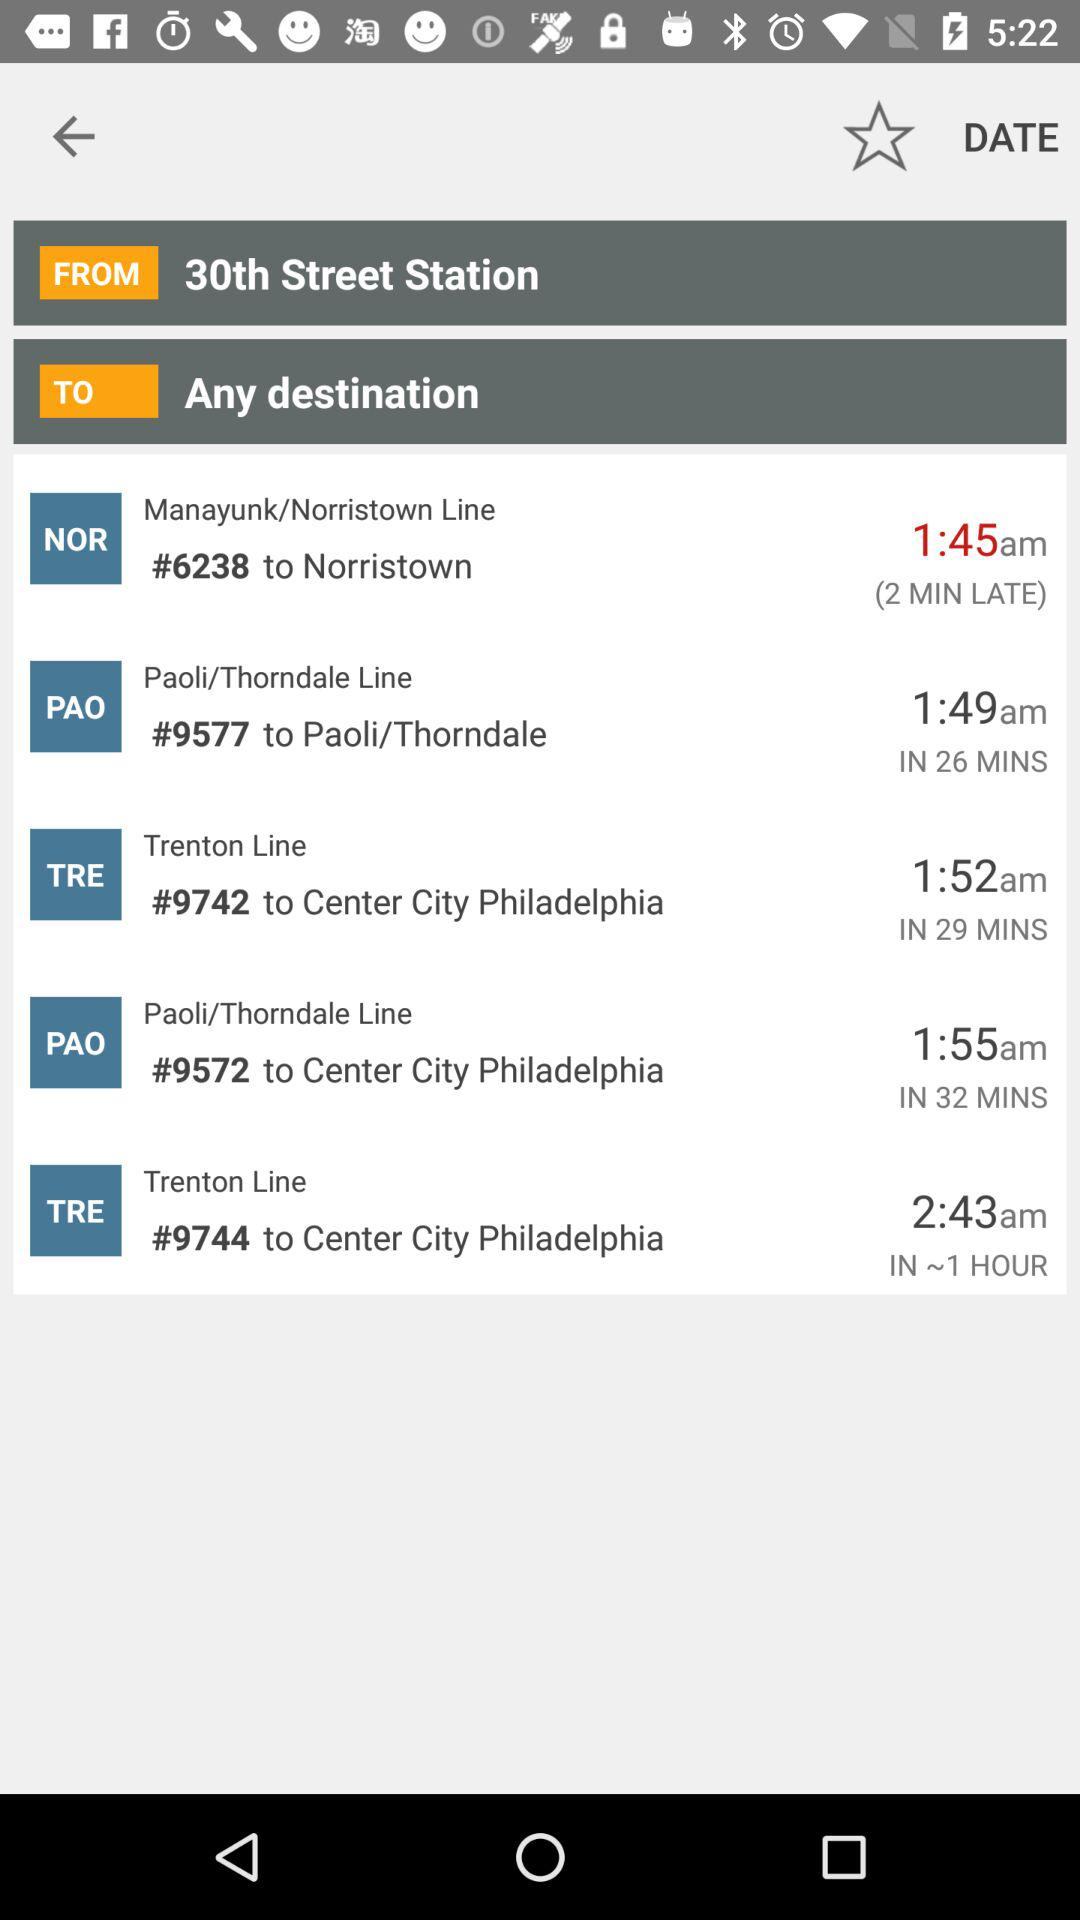What is the origin station name? The origin station name is "30th Street Station". 